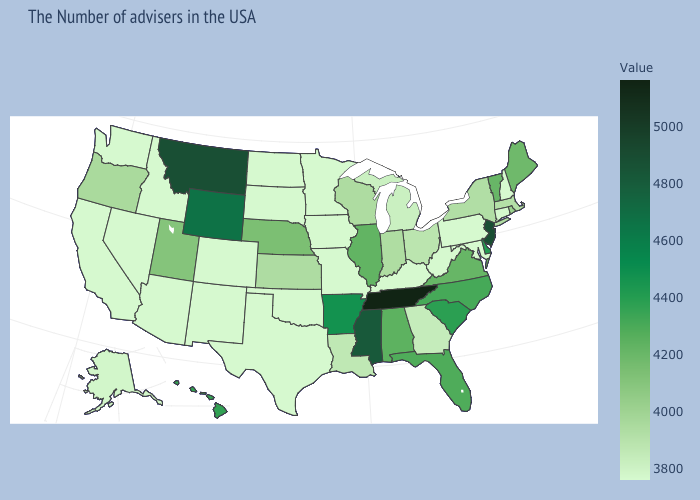Is the legend a continuous bar?
Quick response, please. Yes. Does Pennsylvania have the lowest value in the Northeast?
Concise answer only. Yes. Which states hav the highest value in the West?
Concise answer only. Montana. Among the states that border Missouri , which have the lowest value?
Short answer required. Kentucky, Iowa, Oklahoma. Is the legend a continuous bar?
Give a very brief answer. Yes. Is the legend a continuous bar?
Be succinct. Yes. 